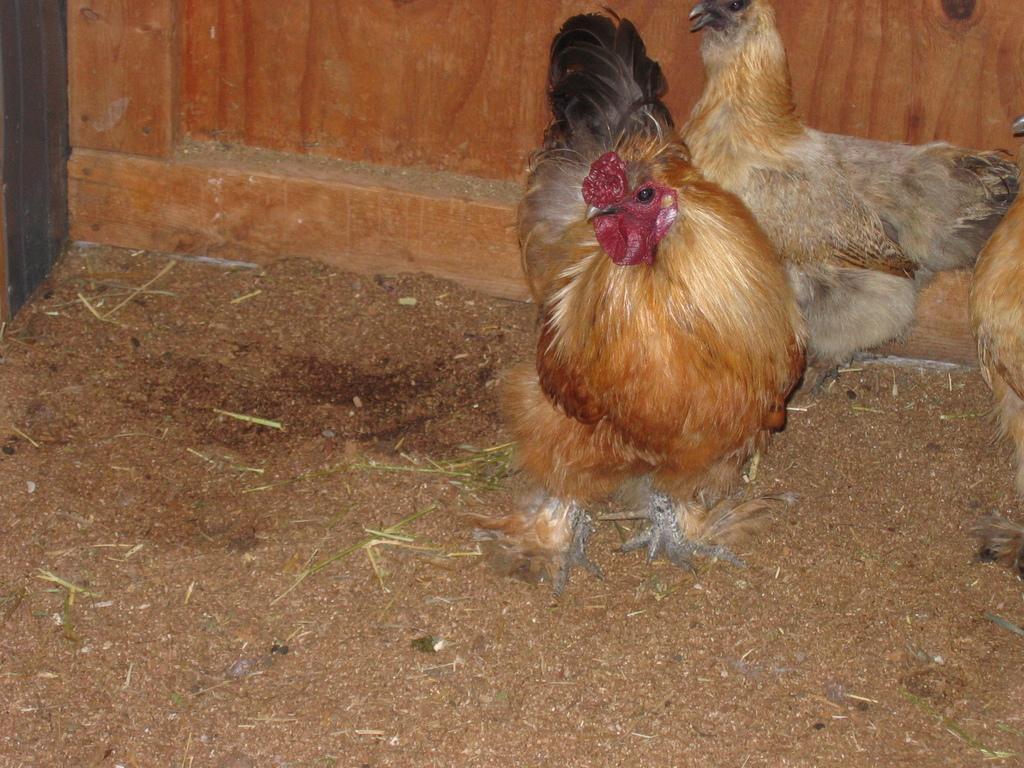In one or two sentences, can you explain what this image depicts? In this picture there are cocks on the right side of the image, on a muddy area. 